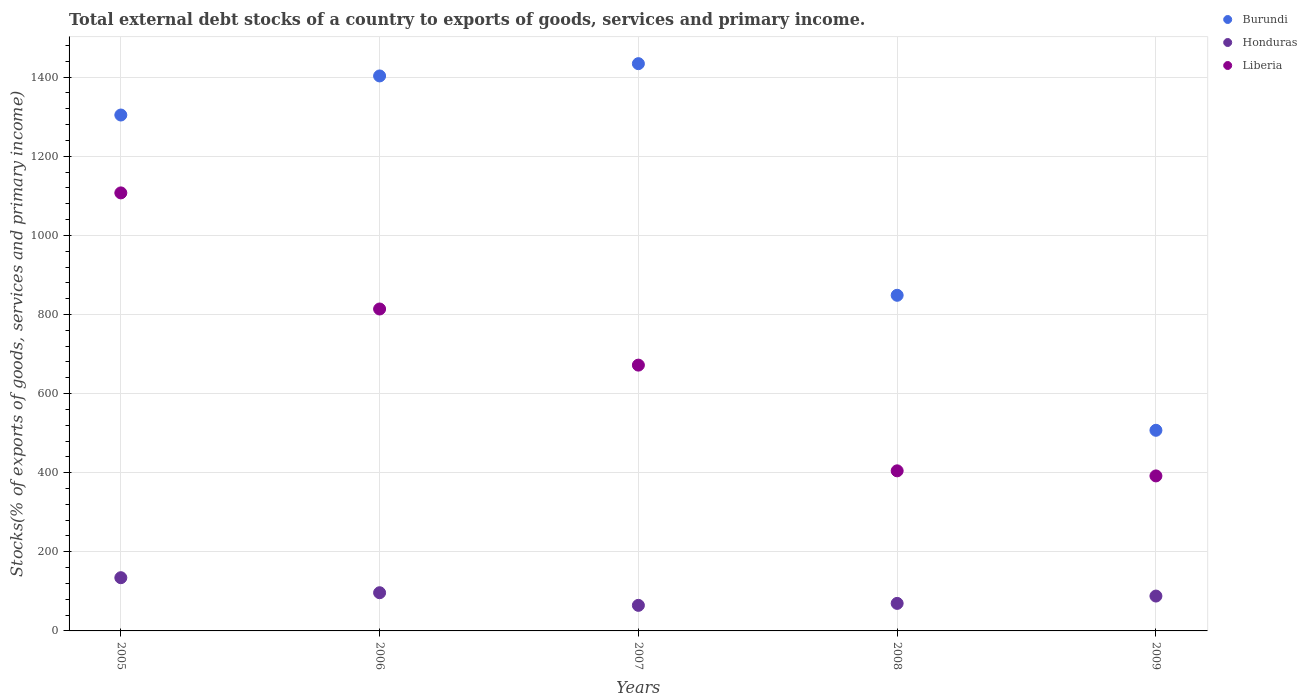What is the total debt stocks in Liberia in 2006?
Keep it short and to the point. 813.87. Across all years, what is the maximum total debt stocks in Liberia?
Your answer should be very brief. 1107.37. Across all years, what is the minimum total debt stocks in Honduras?
Your response must be concise. 64.63. In which year was the total debt stocks in Liberia maximum?
Give a very brief answer. 2005. What is the total total debt stocks in Liberia in the graph?
Your answer should be very brief. 3389.77. What is the difference between the total debt stocks in Liberia in 2005 and that in 2006?
Make the answer very short. 293.5. What is the difference between the total debt stocks in Liberia in 2008 and the total debt stocks in Burundi in 2009?
Provide a succinct answer. -102.48. What is the average total debt stocks in Liberia per year?
Offer a very short reply. 677.95. In the year 2005, what is the difference between the total debt stocks in Burundi and total debt stocks in Honduras?
Make the answer very short. 1169.71. What is the ratio of the total debt stocks in Burundi in 2005 to that in 2008?
Offer a very short reply. 1.54. Is the total debt stocks in Burundi in 2006 less than that in 2008?
Make the answer very short. No. Is the difference between the total debt stocks in Burundi in 2005 and 2008 greater than the difference between the total debt stocks in Honduras in 2005 and 2008?
Your response must be concise. Yes. What is the difference between the highest and the second highest total debt stocks in Liberia?
Give a very brief answer. 293.5. What is the difference between the highest and the lowest total debt stocks in Honduras?
Offer a terse response. 69.92. In how many years, is the total debt stocks in Honduras greater than the average total debt stocks in Honduras taken over all years?
Offer a very short reply. 2. Is the total debt stocks in Burundi strictly greater than the total debt stocks in Honduras over the years?
Your answer should be very brief. Yes. Is the total debt stocks in Honduras strictly less than the total debt stocks in Liberia over the years?
Make the answer very short. Yes. Are the values on the major ticks of Y-axis written in scientific E-notation?
Offer a terse response. No. Does the graph contain grids?
Your answer should be compact. Yes. How many legend labels are there?
Give a very brief answer. 3. How are the legend labels stacked?
Give a very brief answer. Vertical. What is the title of the graph?
Provide a short and direct response. Total external debt stocks of a country to exports of goods, services and primary income. What is the label or title of the Y-axis?
Provide a short and direct response. Stocks(% of exports of goods, services and primary income). What is the Stocks(% of exports of goods, services and primary income) in Burundi in 2005?
Your response must be concise. 1304.26. What is the Stocks(% of exports of goods, services and primary income) of Honduras in 2005?
Make the answer very short. 134.55. What is the Stocks(% of exports of goods, services and primary income) in Liberia in 2005?
Make the answer very short. 1107.37. What is the Stocks(% of exports of goods, services and primary income) of Burundi in 2006?
Make the answer very short. 1403.05. What is the Stocks(% of exports of goods, services and primary income) in Honduras in 2006?
Your answer should be compact. 96.55. What is the Stocks(% of exports of goods, services and primary income) of Liberia in 2006?
Your answer should be compact. 813.87. What is the Stocks(% of exports of goods, services and primary income) of Burundi in 2007?
Offer a very short reply. 1434.09. What is the Stocks(% of exports of goods, services and primary income) of Honduras in 2007?
Give a very brief answer. 64.63. What is the Stocks(% of exports of goods, services and primary income) of Liberia in 2007?
Provide a succinct answer. 671.96. What is the Stocks(% of exports of goods, services and primary income) in Burundi in 2008?
Your answer should be very brief. 848.51. What is the Stocks(% of exports of goods, services and primary income) in Honduras in 2008?
Offer a very short reply. 69.6. What is the Stocks(% of exports of goods, services and primary income) of Liberia in 2008?
Offer a very short reply. 404.72. What is the Stocks(% of exports of goods, services and primary income) in Burundi in 2009?
Provide a short and direct response. 507.2. What is the Stocks(% of exports of goods, services and primary income) in Honduras in 2009?
Give a very brief answer. 88.13. What is the Stocks(% of exports of goods, services and primary income) of Liberia in 2009?
Keep it short and to the point. 391.86. Across all years, what is the maximum Stocks(% of exports of goods, services and primary income) of Burundi?
Offer a terse response. 1434.09. Across all years, what is the maximum Stocks(% of exports of goods, services and primary income) of Honduras?
Give a very brief answer. 134.55. Across all years, what is the maximum Stocks(% of exports of goods, services and primary income) of Liberia?
Ensure brevity in your answer.  1107.37. Across all years, what is the minimum Stocks(% of exports of goods, services and primary income) in Burundi?
Give a very brief answer. 507.2. Across all years, what is the minimum Stocks(% of exports of goods, services and primary income) of Honduras?
Offer a very short reply. 64.63. Across all years, what is the minimum Stocks(% of exports of goods, services and primary income) in Liberia?
Make the answer very short. 391.86. What is the total Stocks(% of exports of goods, services and primary income) in Burundi in the graph?
Ensure brevity in your answer.  5497.11. What is the total Stocks(% of exports of goods, services and primary income) of Honduras in the graph?
Give a very brief answer. 453.46. What is the total Stocks(% of exports of goods, services and primary income) of Liberia in the graph?
Your answer should be very brief. 3389.77. What is the difference between the Stocks(% of exports of goods, services and primary income) in Burundi in 2005 and that in 2006?
Provide a short and direct response. -98.79. What is the difference between the Stocks(% of exports of goods, services and primary income) in Honduras in 2005 and that in 2006?
Keep it short and to the point. 38. What is the difference between the Stocks(% of exports of goods, services and primary income) of Liberia in 2005 and that in 2006?
Provide a succinct answer. 293.5. What is the difference between the Stocks(% of exports of goods, services and primary income) of Burundi in 2005 and that in 2007?
Offer a terse response. -129.83. What is the difference between the Stocks(% of exports of goods, services and primary income) of Honduras in 2005 and that in 2007?
Your response must be concise. 69.92. What is the difference between the Stocks(% of exports of goods, services and primary income) in Liberia in 2005 and that in 2007?
Your answer should be very brief. 435.4. What is the difference between the Stocks(% of exports of goods, services and primary income) in Burundi in 2005 and that in 2008?
Make the answer very short. 455.75. What is the difference between the Stocks(% of exports of goods, services and primary income) of Honduras in 2005 and that in 2008?
Keep it short and to the point. 64.96. What is the difference between the Stocks(% of exports of goods, services and primary income) of Liberia in 2005 and that in 2008?
Offer a terse response. 702.65. What is the difference between the Stocks(% of exports of goods, services and primary income) in Burundi in 2005 and that in 2009?
Your answer should be compact. 797.06. What is the difference between the Stocks(% of exports of goods, services and primary income) in Honduras in 2005 and that in 2009?
Offer a very short reply. 46.42. What is the difference between the Stocks(% of exports of goods, services and primary income) of Liberia in 2005 and that in 2009?
Your answer should be compact. 715.51. What is the difference between the Stocks(% of exports of goods, services and primary income) of Burundi in 2006 and that in 2007?
Give a very brief answer. -31.04. What is the difference between the Stocks(% of exports of goods, services and primary income) of Honduras in 2006 and that in 2007?
Keep it short and to the point. 31.92. What is the difference between the Stocks(% of exports of goods, services and primary income) in Liberia in 2006 and that in 2007?
Provide a succinct answer. 141.91. What is the difference between the Stocks(% of exports of goods, services and primary income) of Burundi in 2006 and that in 2008?
Keep it short and to the point. 554.54. What is the difference between the Stocks(% of exports of goods, services and primary income) of Honduras in 2006 and that in 2008?
Give a very brief answer. 26.96. What is the difference between the Stocks(% of exports of goods, services and primary income) of Liberia in 2006 and that in 2008?
Provide a succinct answer. 409.15. What is the difference between the Stocks(% of exports of goods, services and primary income) of Burundi in 2006 and that in 2009?
Offer a terse response. 895.85. What is the difference between the Stocks(% of exports of goods, services and primary income) in Honduras in 2006 and that in 2009?
Ensure brevity in your answer.  8.42. What is the difference between the Stocks(% of exports of goods, services and primary income) of Liberia in 2006 and that in 2009?
Provide a succinct answer. 422.01. What is the difference between the Stocks(% of exports of goods, services and primary income) of Burundi in 2007 and that in 2008?
Your answer should be very brief. 585.58. What is the difference between the Stocks(% of exports of goods, services and primary income) of Honduras in 2007 and that in 2008?
Offer a very short reply. -4.97. What is the difference between the Stocks(% of exports of goods, services and primary income) of Liberia in 2007 and that in 2008?
Ensure brevity in your answer.  267.24. What is the difference between the Stocks(% of exports of goods, services and primary income) of Burundi in 2007 and that in 2009?
Give a very brief answer. 926.89. What is the difference between the Stocks(% of exports of goods, services and primary income) of Honduras in 2007 and that in 2009?
Make the answer very short. -23.5. What is the difference between the Stocks(% of exports of goods, services and primary income) in Liberia in 2007 and that in 2009?
Your answer should be very brief. 280.1. What is the difference between the Stocks(% of exports of goods, services and primary income) of Burundi in 2008 and that in 2009?
Keep it short and to the point. 341.31. What is the difference between the Stocks(% of exports of goods, services and primary income) of Honduras in 2008 and that in 2009?
Provide a succinct answer. -18.53. What is the difference between the Stocks(% of exports of goods, services and primary income) in Liberia in 2008 and that in 2009?
Give a very brief answer. 12.86. What is the difference between the Stocks(% of exports of goods, services and primary income) of Burundi in 2005 and the Stocks(% of exports of goods, services and primary income) of Honduras in 2006?
Keep it short and to the point. 1207.71. What is the difference between the Stocks(% of exports of goods, services and primary income) in Burundi in 2005 and the Stocks(% of exports of goods, services and primary income) in Liberia in 2006?
Offer a very short reply. 490.39. What is the difference between the Stocks(% of exports of goods, services and primary income) of Honduras in 2005 and the Stocks(% of exports of goods, services and primary income) of Liberia in 2006?
Your response must be concise. -679.32. What is the difference between the Stocks(% of exports of goods, services and primary income) of Burundi in 2005 and the Stocks(% of exports of goods, services and primary income) of Honduras in 2007?
Provide a short and direct response. 1239.63. What is the difference between the Stocks(% of exports of goods, services and primary income) of Burundi in 2005 and the Stocks(% of exports of goods, services and primary income) of Liberia in 2007?
Your response must be concise. 632.3. What is the difference between the Stocks(% of exports of goods, services and primary income) in Honduras in 2005 and the Stocks(% of exports of goods, services and primary income) in Liberia in 2007?
Ensure brevity in your answer.  -537.41. What is the difference between the Stocks(% of exports of goods, services and primary income) of Burundi in 2005 and the Stocks(% of exports of goods, services and primary income) of Honduras in 2008?
Ensure brevity in your answer.  1234.66. What is the difference between the Stocks(% of exports of goods, services and primary income) in Burundi in 2005 and the Stocks(% of exports of goods, services and primary income) in Liberia in 2008?
Ensure brevity in your answer.  899.54. What is the difference between the Stocks(% of exports of goods, services and primary income) in Honduras in 2005 and the Stocks(% of exports of goods, services and primary income) in Liberia in 2008?
Give a very brief answer. -270.17. What is the difference between the Stocks(% of exports of goods, services and primary income) of Burundi in 2005 and the Stocks(% of exports of goods, services and primary income) of Honduras in 2009?
Your response must be concise. 1216.13. What is the difference between the Stocks(% of exports of goods, services and primary income) of Burundi in 2005 and the Stocks(% of exports of goods, services and primary income) of Liberia in 2009?
Give a very brief answer. 912.4. What is the difference between the Stocks(% of exports of goods, services and primary income) of Honduras in 2005 and the Stocks(% of exports of goods, services and primary income) of Liberia in 2009?
Provide a short and direct response. -257.31. What is the difference between the Stocks(% of exports of goods, services and primary income) of Burundi in 2006 and the Stocks(% of exports of goods, services and primary income) of Honduras in 2007?
Your answer should be very brief. 1338.42. What is the difference between the Stocks(% of exports of goods, services and primary income) of Burundi in 2006 and the Stocks(% of exports of goods, services and primary income) of Liberia in 2007?
Your response must be concise. 731.09. What is the difference between the Stocks(% of exports of goods, services and primary income) in Honduras in 2006 and the Stocks(% of exports of goods, services and primary income) in Liberia in 2007?
Ensure brevity in your answer.  -575.41. What is the difference between the Stocks(% of exports of goods, services and primary income) of Burundi in 2006 and the Stocks(% of exports of goods, services and primary income) of Honduras in 2008?
Keep it short and to the point. 1333.45. What is the difference between the Stocks(% of exports of goods, services and primary income) of Burundi in 2006 and the Stocks(% of exports of goods, services and primary income) of Liberia in 2008?
Your answer should be compact. 998.33. What is the difference between the Stocks(% of exports of goods, services and primary income) of Honduras in 2006 and the Stocks(% of exports of goods, services and primary income) of Liberia in 2008?
Make the answer very short. -308.17. What is the difference between the Stocks(% of exports of goods, services and primary income) in Burundi in 2006 and the Stocks(% of exports of goods, services and primary income) in Honduras in 2009?
Your response must be concise. 1314.92. What is the difference between the Stocks(% of exports of goods, services and primary income) of Burundi in 2006 and the Stocks(% of exports of goods, services and primary income) of Liberia in 2009?
Offer a very short reply. 1011.19. What is the difference between the Stocks(% of exports of goods, services and primary income) of Honduras in 2006 and the Stocks(% of exports of goods, services and primary income) of Liberia in 2009?
Keep it short and to the point. -295.31. What is the difference between the Stocks(% of exports of goods, services and primary income) in Burundi in 2007 and the Stocks(% of exports of goods, services and primary income) in Honduras in 2008?
Your answer should be compact. 1364.5. What is the difference between the Stocks(% of exports of goods, services and primary income) of Burundi in 2007 and the Stocks(% of exports of goods, services and primary income) of Liberia in 2008?
Your answer should be very brief. 1029.37. What is the difference between the Stocks(% of exports of goods, services and primary income) in Honduras in 2007 and the Stocks(% of exports of goods, services and primary income) in Liberia in 2008?
Provide a short and direct response. -340.09. What is the difference between the Stocks(% of exports of goods, services and primary income) of Burundi in 2007 and the Stocks(% of exports of goods, services and primary income) of Honduras in 2009?
Your answer should be compact. 1345.96. What is the difference between the Stocks(% of exports of goods, services and primary income) in Burundi in 2007 and the Stocks(% of exports of goods, services and primary income) in Liberia in 2009?
Provide a succinct answer. 1042.23. What is the difference between the Stocks(% of exports of goods, services and primary income) in Honduras in 2007 and the Stocks(% of exports of goods, services and primary income) in Liberia in 2009?
Provide a succinct answer. -327.23. What is the difference between the Stocks(% of exports of goods, services and primary income) of Burundi in 2008 and the Stocks(% of exports of goods, services and primary income) of Honduras in 2009?
Offer a terse response. 760.38. What is the difference between the Stocks(% of exports of goods, services and primary income) of Burundi in 2008 and the Stocks(% of exports of goods, services and primary income) of Liberia in 2009?
Your answer should be very brief. 456.65. What is the difference between the Stocks(% of exports of goods, services and primary income) in Honduras in 2008 and the Stocks(% of exports of goods, services and primary income) in Liberia in 2009?
Give a very brief answer. -322.26. What is the average Stocks(% of exports of goods, services and primary income) in Burundi per year?
Keep it short and to the point. 1099.42. What is the average Stocks(% of exports of goods, services and primary income) of Honduras per year?
Offer a terse response. 90.69. What is the average Stocks(% of exports of goods, services and primary income) of Liberia per year?
Offer a terse response. 677.95. In the year 2005, what is the difference between the Stocks(% of exports of goods, services and primary income) in Burundi and Stocks(% of exports of goods, services and primary income) in Honduras?
Provide a short and direct response. 1169.71. In the year 2005, what is the difference between the Stocks(% of exports of goods, services and primary income) of Burundi and Stocks(% of exports of goods, services and primary income) of Liberia?
Your answer should be compact. 196.89. In the year 2005, what is the difference between the Stocks(% of exports of goods, services and primary income) in Honduras and Stocks(% of exports of goods, services and primary income) in Liberia?
Your response must be concise. -972.81. In the year 2006, what is the difference between the Stocks(% of exports of goods, services and primary income) in Burundi and Stocks(% of exports of goods, services and primary income) in Honduras?
Provide a succinct answer. 1306.5. In the year 2006, what is the difference between the Stocks(% of exports of goods, services and primary income) in Burundi and Stocks(% of exports of goods, services and primary income) in Liberia?
Your answer should be very brief. 589.18. In the year 2006, what is the difference between the Stocks(% of exports of goods, services and primary income) in Honduras and Stocks(% of exports of goods, services and primary income) in Liberia?
Your answer should be very brief. -717.31. In the year 2007, what is the difference between the Stocks(% of exports of goods, services and primary income) in Burundi and Stocks(% of exports of goods, services and primary income) in Honduras?
Make the answer very short. 1369.46. In the year 2007, what is the difference between the Stocks(% of exports of goods, services and primary income) in Burundi and Stocks(% of exports of goods, services and primary income) in Liberia?
Provide a short and direct response. 762.13. In the year 2007, what is the difference between the Stocks(% of exports of goods, services and primary income) in Honduras and Stocks(% of exports of goods, services and primary income) in Liberia?
Provide a succinct answer. -607.33. In the year 2008, what is the difference between the Stocks(% of exports of goods, services and primary income) of Burundi and Stocks(% of exports of goods, services and primary income) of Honduras?
Make the answer very short. 778.91. In the year 2008, what is the difference between the Stocks(% of exports of goods, services and primary income) in Burundi and Stocks(% of exports of goods, services and primary income) in Liberia?
Make the answer very short. 443.79. In the year 2008, what is the difference between the Stocks(% of exports of goods, services and primary income) of Honduras and Stocks(% of exports of goods, services and primary income) of Liberia?
Keep it short and to the point. -335.12. In the year 2009, what is the difference between the Stocks(% of exports of goods, services and primary income) in Burundi and Stocks(% of exports of goods, services and primary income) in Honduras?
Offer a very short reply. 419.07. In the year 2009, what is the difference between the Stocks(% of exports of goods, services and primary income) in Burundi and Stocks(% of exports of goods, services and primary income) in Liberia?
Your answer should be compact. 115.34. In the year 2009, what is the difference between the Stocks(% of exports of goods, services and primary income) in Honduras and Stocks(% of exports of goods, services and primary income) in Liberia?
Give a very brief answer. -303.73. What is the ratio of the Stocks(% of exports of goods, services and primary income) in Burundi in 2005 to that in 2006?
Provide a short and direct response. 0.93. What is the ratio of the Stocks(% of exports of goods, services and primary income) in Honduras in 2005 to that in 2006?
Offer a very short reply. 1.39. What is the ratio of the Stocks(% of exports of goods, services and primary income) in Liberia in 2005 to that in 2006?
Your answer should be compact. 1.36. What is the ratio of the Stocks(% of exports of goods, services and primary income) in Burundi in 2005 to that in 2007?
Your response must be concise. 0.91. What is the ratio of the Stocks(% of exports of goods, services and primary income) in Honduras in 2005 to that in 2007?
Your answer should be compact. 2.08. What is the ratio of the Stocks(% of exports of goods, services and primary income) of Liberia in 2005 to that in 2007?
Provide a short and direct response. 1.65. What is the ratio of the Stocks(% of exports of goods, services and primary income) of Burundi in 2005 to that in 2008?
Your response must be concise. 1.54. What is the ratio of the Stocks(% of exports of goods, services and primary income) of Honduras in 2005 to that in 2008?
Provide a succinct answer. 1.93. What is the ratio of the Stocks(% of exports of goods, services and primary income) of Liberia in 2005 to that in 2008?
Make the answer very short. 2.74. What is the ratio of the Stocks(% of exports of goods, services and primary income) of Burundi in 2005 to that in 2009?
Provide a succinct answer. 2.57. What is the ratio of the Stocks(% of exports of goods, services and primary income) of Honduras in 2005 to that in 2009?
Your response must be concise. 1.53. What is the ratio of the Stocks(% of exports of goods, services and primary income) of Liberia in 2005 to that in 2009?
Make the answer very short. 2.83. What is the ratio of the Stocks(% of exports of goods, services and primary income) of Burundi in 2006 to that in 2007?
Your answer should be compact. 0.98. What is the ratio of the Stocks(% of exports of goods, services and primary income) of Honduras in 2006 to that in 2007?
Offer a very short reply. 1.49. What is the ratio of the Stocks(% of exports of goods, services and primary income) in Liberia in 2006 to that in 2007?
Your answer should be compact. 1.21. What is the ratio of the Stocks(% of exports of goods, services and primary income) in Burundi in 2006 to that in 2008?
Provide a succinct answer. 1.65. What is the ratio of the Stocks(% of exports of goods, services and primary income) in Honduras in 2006 to that in 2008?
Keep it short and to the point. 1.39. What is the ratio of the Stocks(% of exports of goods, services and primary income) of Liberia in 2006 to that in 2008?
Your answer should be very brief. 2.01. What is the ratio of the Stocks(% of exports of goods, services and primary income) of Burundi in 2006 to that in 2009?
Offer a very short reply. 2.77. What is the ratio of the Stocks(% of exports of goods, services and primary income) of Honduras in 2006 to that in 2009?
Keep it short and to the point. 1.1. What is the ratio of the Stocks(% of exports of goods, services and primary income) of Liberia in 2006 to that in 2009?
Your answer should be compact. 2.08. What is the ratio of the Stocks(% of exports of goods, services and primary income) of Burundi in 2007 to that in 2008?
Your answer should be compact. 1.69. What is the ratio of the Stocks(% of exports of goods, services and primary income) of Liberia in 2007 to that in 2008?
Your answer should be compact. 1.66. What is the ratio of the Stocks(% of exports of goods, services and primary income) in Burundi in 2007 to that in 2009?
Give a very brief answer. 2.83. What is the ratio of the Stocks(% of exports of goods, services and primary income) in Honduras in 2007 to that in 2009?
Your answer should be compact. 0.73. What is the ratio of the Stocks(% of exports of goods, services and primary income) of Liberia in 2007 to that in 2009?
Make the answer very short. 1.71. What is the ratio of the Stocks(% of exports of goods, services and primary income) in Burundi in 2008 to that in 2009?
Keep it short and to the point. 1.67. What is the ratio of the Stocks(% of exports of goods, services and primary income) of Honduras in 2008 to that in 2009?
Give a very brief answer. 0.79. What is the ratio of the Stocks(% of exports of goods, services and primary income) in Liberia in 2008 to that in 2009?
Make the answer very short. 1.03. What is the difference between the highest and the second highest Stocks(% of exports of goods, services and primary income) of Burundi?
Your response must be concise. 31.04. What is the difference between the highest and the second highest Stocks(% of exports of goods, services and primary income) in Honduras?
Provide a succinct answer. 38. What is the difference between the highest and the second highest Stocks(% of exports of goods, services and primary income) of Liberia?
Your response must be concise. 293.5. What is the difference between the highest and the lowest Stocks(% of exports of goods, services and primary income) in Burundi?
Provide a succinct answer. 926.89. What is the difference between the highest and the lowest Stocks(% of exports of goods, services and primary income) in Honduras?
Provide a short and direct response. 69.92. What is the difference between the highest and the lowest Stocks(% of exports of goods, services and primary income) of Liberia?
Make the answer very short. 715.51. 